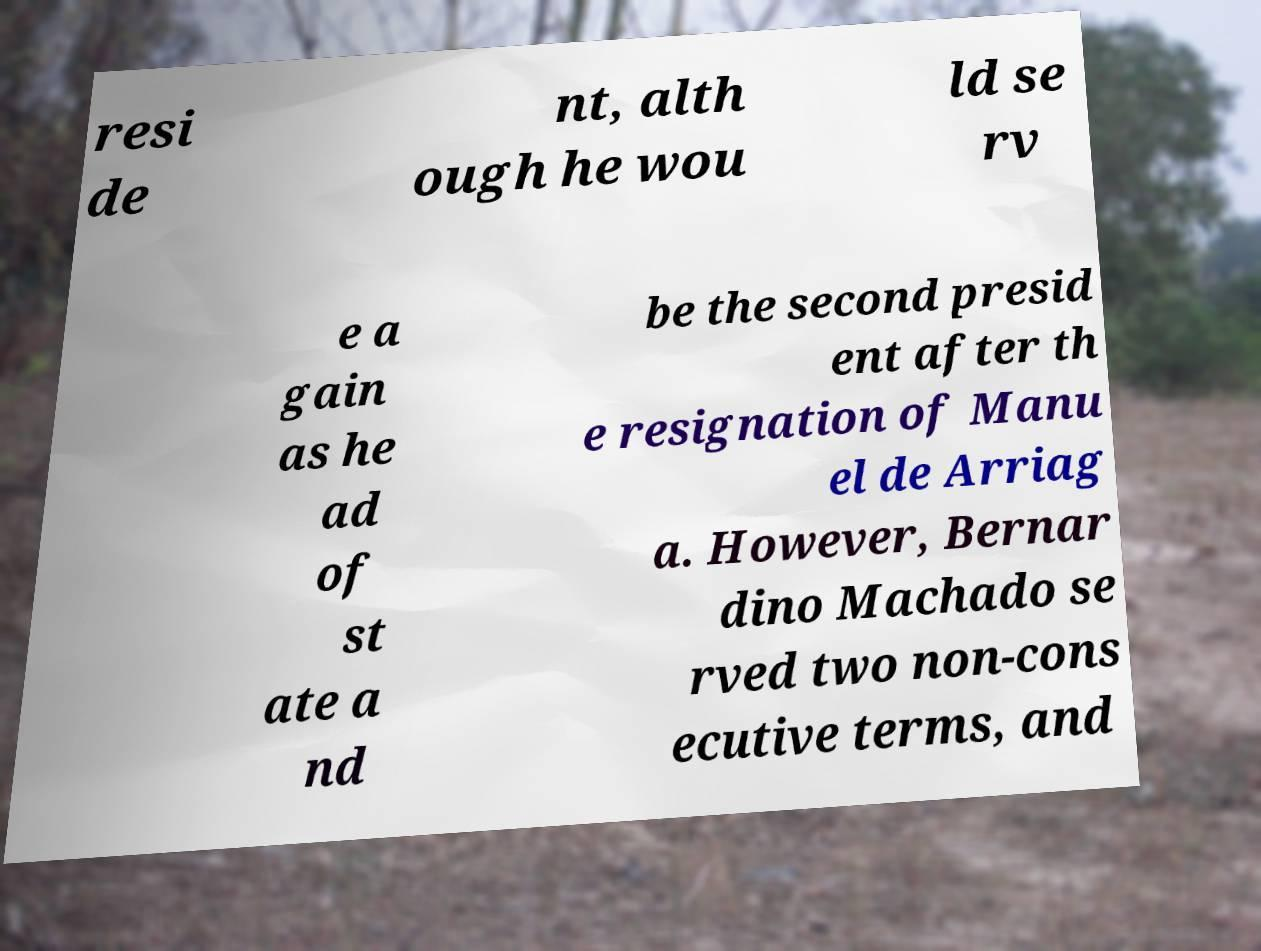There's text embedded in this image that I need extracted. Can you transcribe it verbatim? resi de nt, alth ough he wou ld se rv e a gain as he ad of st ate a nd be the second presid ent after th e resignation of Manu el de Arriag a. However, Bernar dino Machado se rved two non-cons ecutive terms, and 